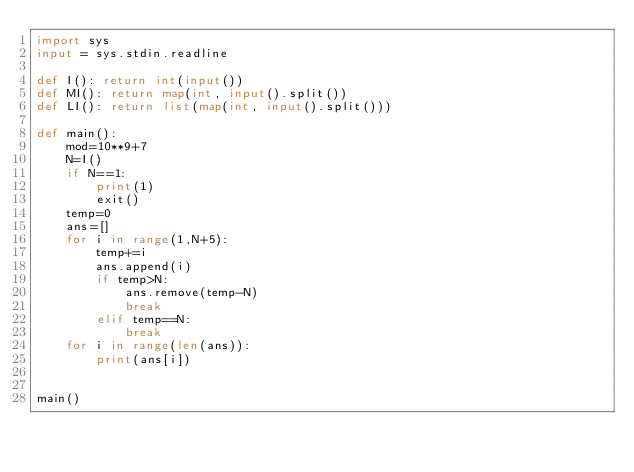Convert code to text. <code><loc_0><loc_0><loc_500><loc_500><_Python_>import sys
input = sys.stdin.readline

def I(): return int(input())
def MI(): return map(int, input().split())
def LI(): return list(map(int, input().split()))

def main():
    mod=10**9+7
    N=I()
    if N==1:
        print(1)
        exit()
    temp=0
    ans=[]
    for i in range(1,N+5):
        temp+=i
        ans.append(i)
        if temp>N:
            ans.remove(temp-N)
            break
        elif temp==N:
            break
    for i in range(len(ans)):
        print(ans[i])
        

main()
</code> 